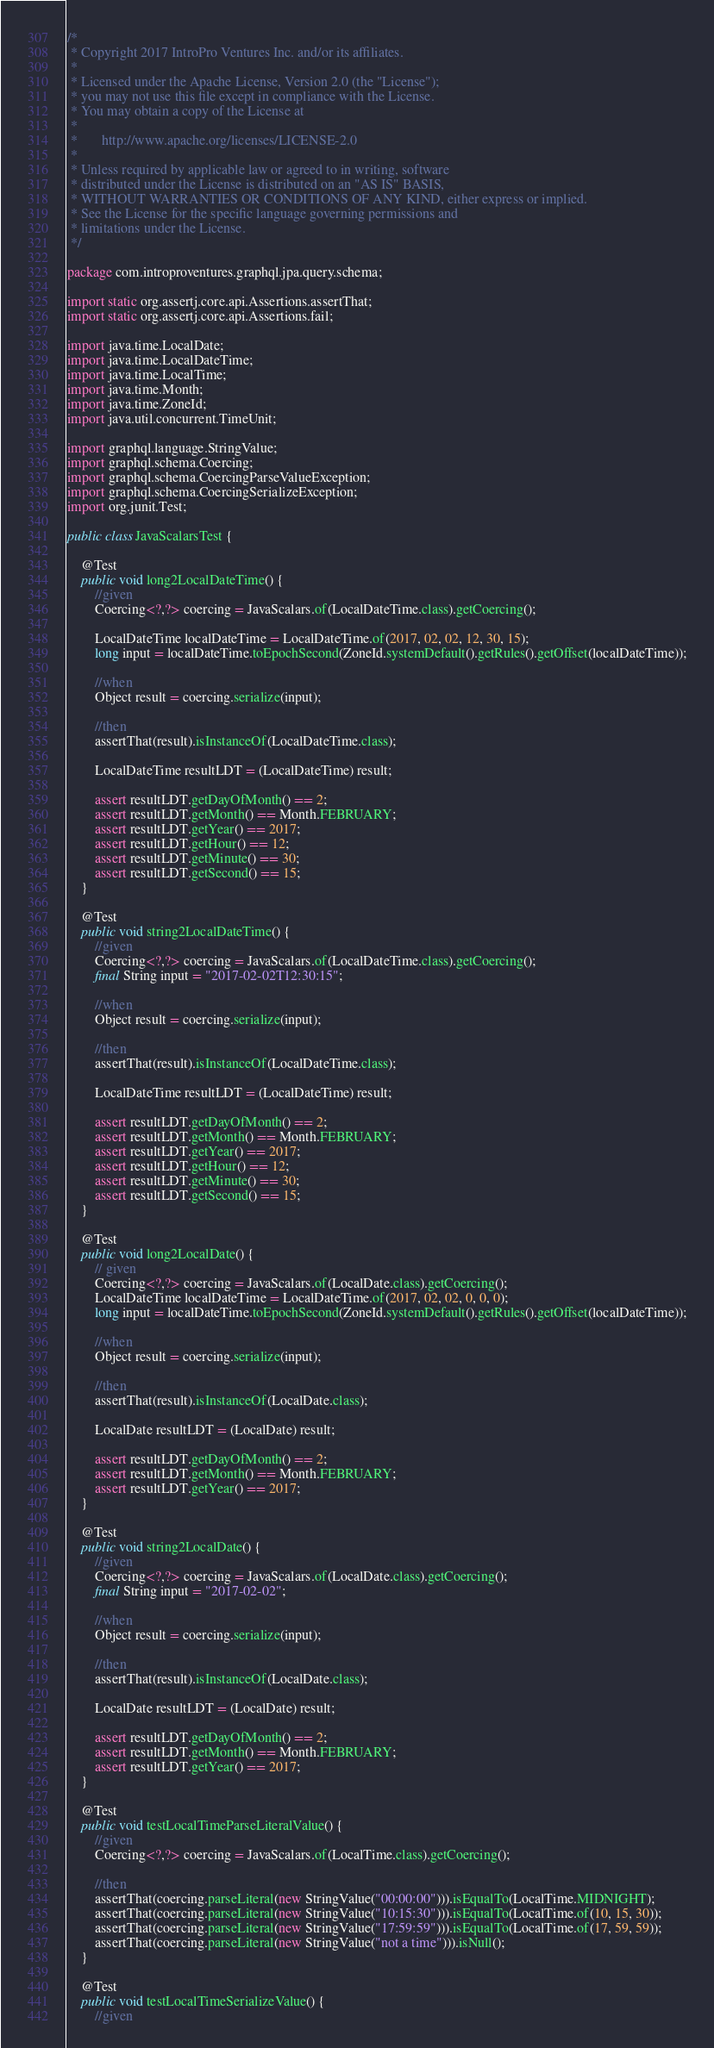<code> <loc_0><loc_0><loc_500><loc_500><_Java_>/*
 * Copyright 2017 IntroPro Ventures Inc. and/or its affiliates.
 *
 * Licensed under the Apache License, Version 2.0 (the "License");
 * you may not use this file except in compliance with the License.
 * You may obtain a copy of the License at
 *
 *       http://www.apache.org/licenses/LICENSE-2.0
 *
 * Unless required by applicable law or agreed to in writing, software
 * distributed under the License is distributed on an "AS IS" BASIS,
 * WITHOUT WARRANTIES OR CONDITIONS OF ANY KIND, either express or implied.
 * See the License for the specific language governing permissions and
 * limitations under the License.
 */

package com.introproventures.graphql.jpa.query.schema;

import static org.assertj.core.api.Assertions.assertThat;
import static org.assertj.core.api.Assertions.fail;

import java.time.LocalDate;
import java.time.LocalDateTime;
import java.time.LocalTime;
import java.time.Month;
import java.time.ZoneId;
import java.util.concurrent.TimeUnit;

import graphql.language.StringValue;
import graphql.schema.Coercing;
import graphql.schema.CoercingParseValueException;
import graphql.schema.CoercingSerializeException;
import org.junit.Test;

public class JavaScalarsTest {

    @Test
    public void long2LocalDateTime() {
        //given
        Coercing<?,?> coercing = JavaScalars.of(LocalDateTime.class).getCoercing();

        LocalDateTime localDateTime = LocalDateTime.of(2017, 02, 02, 12, 30, 15);
        long input = localDateTime.toEpochSecond(ZoneId.systemDefault().getRules().getOffset(localDateTime));

        //when
        Object result = coercing.serialize(input);

        //then
        assertThat(result).isInstanceOf(LocalDateTime.class);

        LocalDateTime resultLDT = (LocalDateTime) result;
        
        assert resultLDT.getDayOfMonth() == 2;
        assert resultLDT.getMonth() == Month.FEBRUARY;
        assert resultLDT.getYear() == 2017;
        assert resultLDT.getHour() == 12;
        assert resultLDT.getMinute() == 30;
        assert resultLDT.getSecond() == 15;
    }

    @Test
    public void string2LocalDateTime() {
        //given
        Coercing<?,?> coercing = JavaScalars.of(LocalDateTime.class).getCoercing();
        final String input = "2017-02-02T12:30:15";

        //when
        Object result = coercing.serialize(input);

        //then
        assertThat(result).isInstanceOf(LocalDateTime.class);

        LocalDateTime resultLDT = (LocalDateTime) result;
        
        assert resultLDT.getDayOfMonth() == 2;
        assert resultLDT.getMonth() == Month.FEBRUARY;
        assert resultLDT.getYear() == 2017;
        assert resultLDT.getHour() == 12;
        assert resultLDT.getMinute() == 30;
        assert resultLDT.getSecond() == 15;
    }

    @Test
    public void long2LocalDate() {
        // given
        Coercing<?,?> coercing = JavaScalars.of(LocalDate.class).getCoercing();
        LocalDateTime localDateTime = LocalDateTime.of(2017, 02, 02, 0, 0, 0);
        long input = localDateTime.toEpochSecond(ZoneId.systemDefault().getRules().getOffset(localDateTime));

        //when
        Object result = coercing.serialize(input);

        //then
        assertThat(result).isInstanceOf(LocalDate.class);

        LocalDate resultLDT = (LocalDate) result;
        
        assert resultLDT.getDayOfMonth() == 2;
        assert resultLDT.getMonth() == Month.FEBRUARY;
        assert resultLDT.getYear() == 2017;
    }

    @Test
    public void string2LocalDate() {
        //given
        Coercing<?,?> coercing = JavaScalars.of(LocalDate.class).getCoercing();
        final String input = "2017-02-02";

        //when
        Object result = coercing.serialize(input);

        //then
        assertThat(result).isInstanceOf(LocalDate.class);

        LocalDate resultLDT = (LocalDate) result;
        
        assert resultLDT.getDayOfMonth() == 2;
        assert resultLDT.getMonth() == Month.FEBRUARY;
        assert resultLDT.getYear() == 2017;
    }
    
    @Test
    public void testLocalTimeParseLiteralValue() {
        //given
        Coercing<?,?> coercing = JavaScalars.of(LocalTime.class).getCoercing();

        //then
        assertThat(coercing.parseLiteral(new StringValue("00:00:00"))).isEqualTo(LocalTime.MIDNIGHT);
        assertThat(coercing.parseLiteral(new StringValue("10:15:30"))).isEqualTo(LocalTime.of(10, 15, 30));
        assertThat(coercing.parseLiteral(new StringValue("17:59:59"))).isEqualTo(LocalTime.of(17, 59, 59));
        assertThat(coercing.parseLiteral(new StringValue("not a time"))).isNull();
    }
    
    @Test
    public void testLocalTimeSerializeValue() {
        //given</code> 